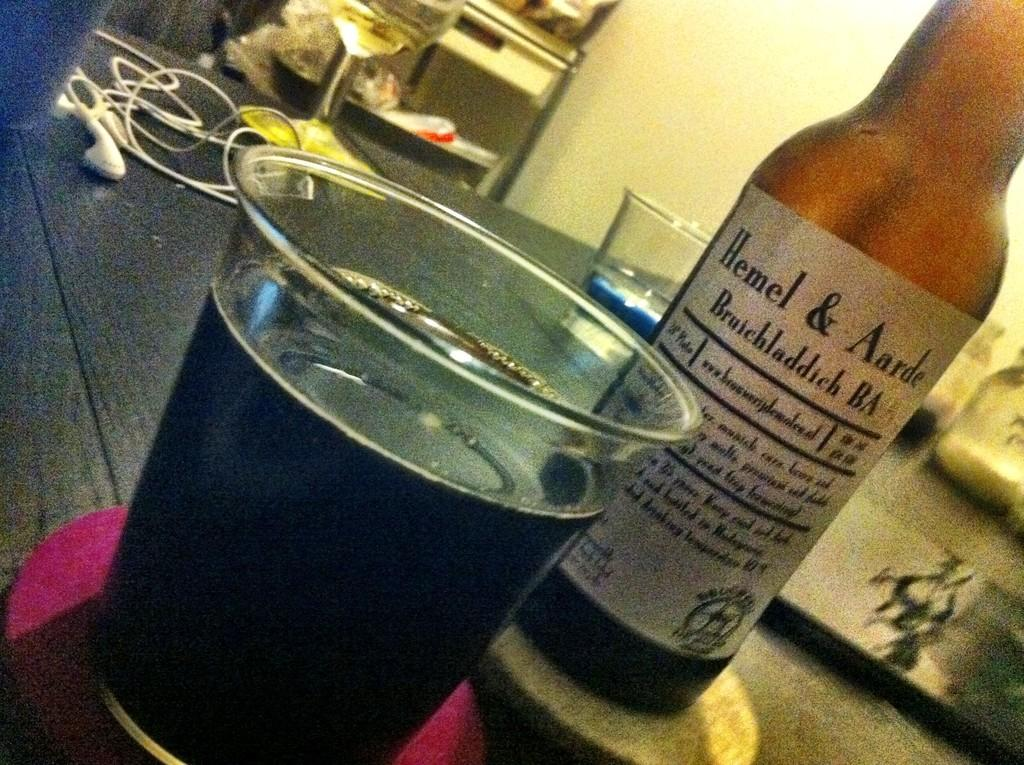What is in the glass that is visible in the image? There is a glass filled with a drink in the image. What is located beside the glass? There is a bottle beside the glass. What type of audio accessory is present in the image? Earphones are present in the image. How many other glasses can be seen on the table in the image? There are other glasses on a table in the image. What can be seen in the background of the image? There is a wall in the background of the image. How does the glass expand in the image? The glass does not expand in the image; it is a static object containing a drink. What type of motion is depicted in the image? There is no motion depicted in the image; all objects are stationary. 